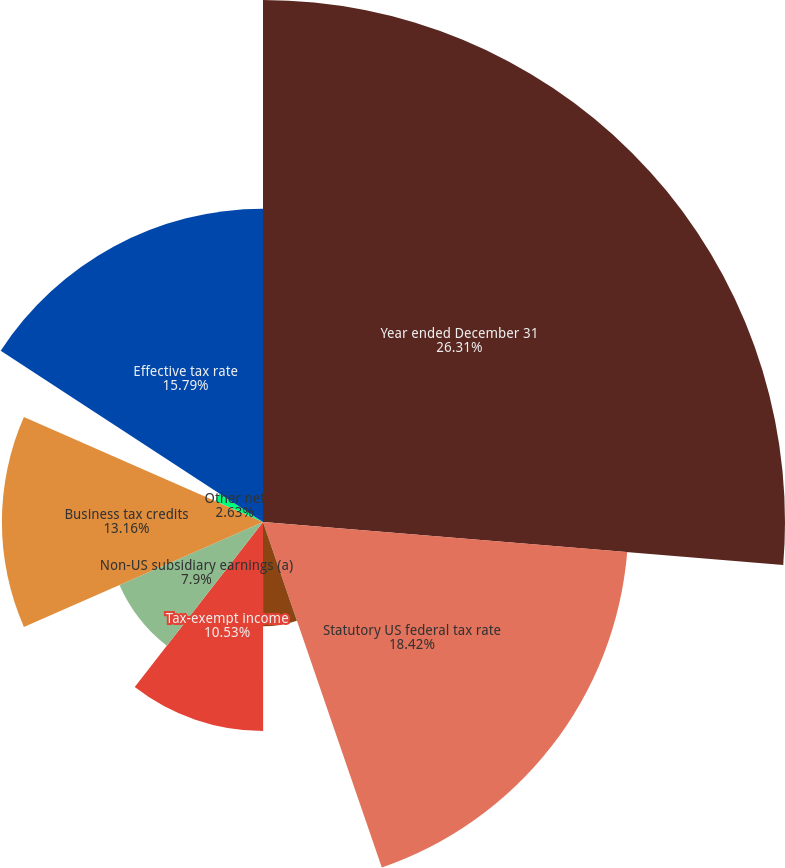Convert chart to OTSL. <chart><loc_0><loc_0><loc_500><loc_500><pie_chart><fcel>Year ended December 31<fcel>Statutory US federal tax rate<fcel>US state and local income<fcel>Tax-exempt income<fcel>Non-US subsidiary earnings (a)<fcel>Business tax credits<fcel>Nondeductible legal expense<fcel>Other net<fcel>Effective tax rate<nl><fcel>26.31%<fcel>18.42%<fcel>5.26%<fcel>10.53%<fcel>7.9%<fcel>13.16%<fcel>0.0%<fcel>2.63%<fcel>15.79%<nl></chart> 